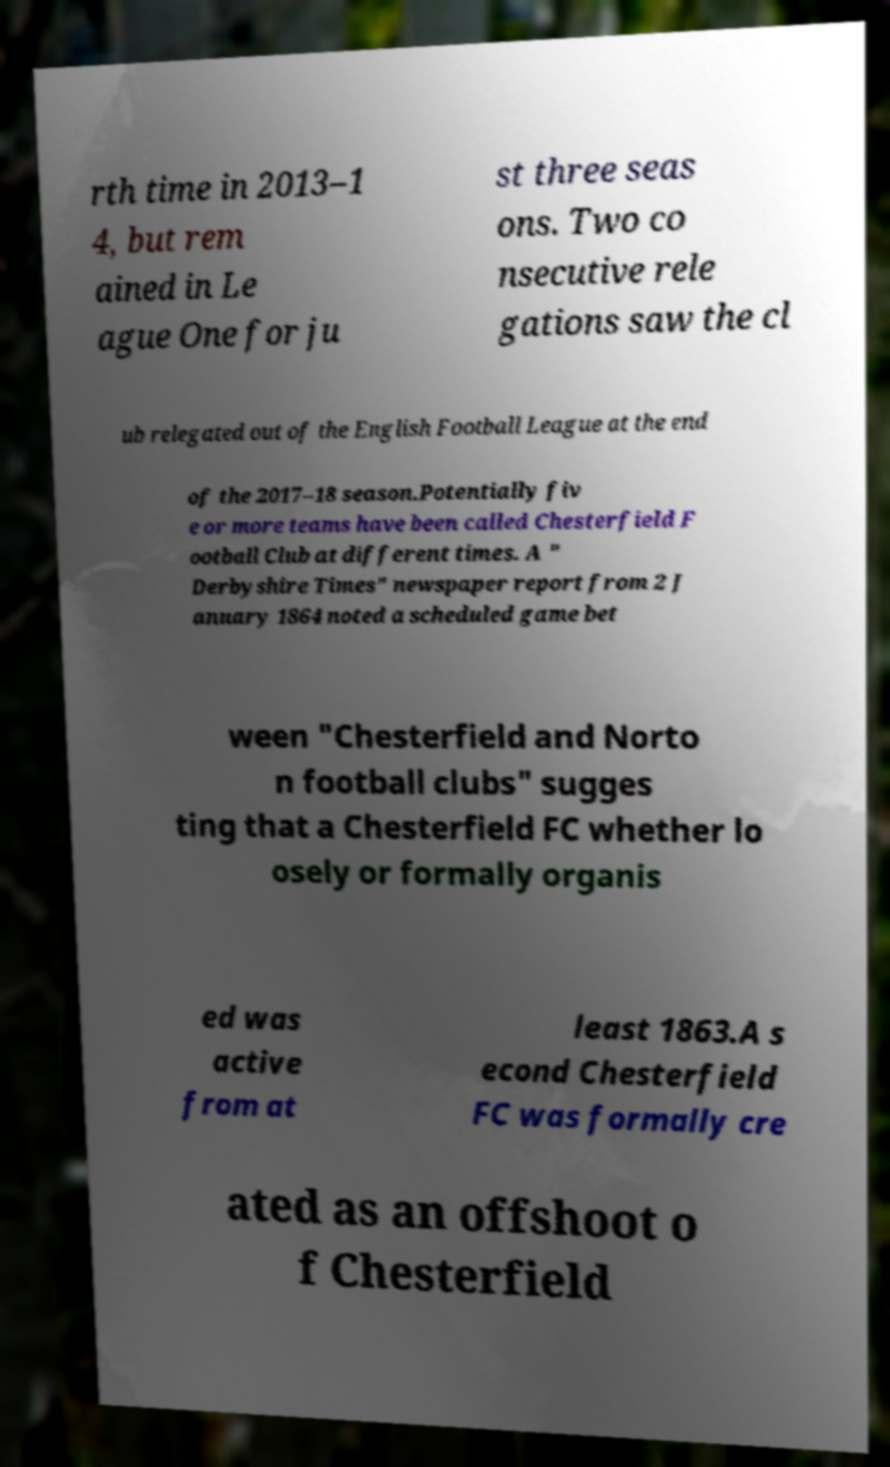Could you assist in decoding the text presented in this image and type it out clearly? rth time in 2013–1 4, but rem ained in Le ague One for ju st three seas ons. Two co nsecutive rele gations saw the cl ub relegated out of the English Football League at the end of the 2017–18 season.Potentially fiv e or more teams have been called Chesterfield F ootball Club at different times. A " Derbyshire Times" newspaper report from 2 J anuary 1864 noted a scheduled game bet ween "Chesterfield and Norto n football clubs" sugges ting that a Chesterfield FC whether lo osely or formally organis ed was active from at least 1863.A s econd Chesterfield FC was formally cre ated as an offshoot o f Chesterfield 